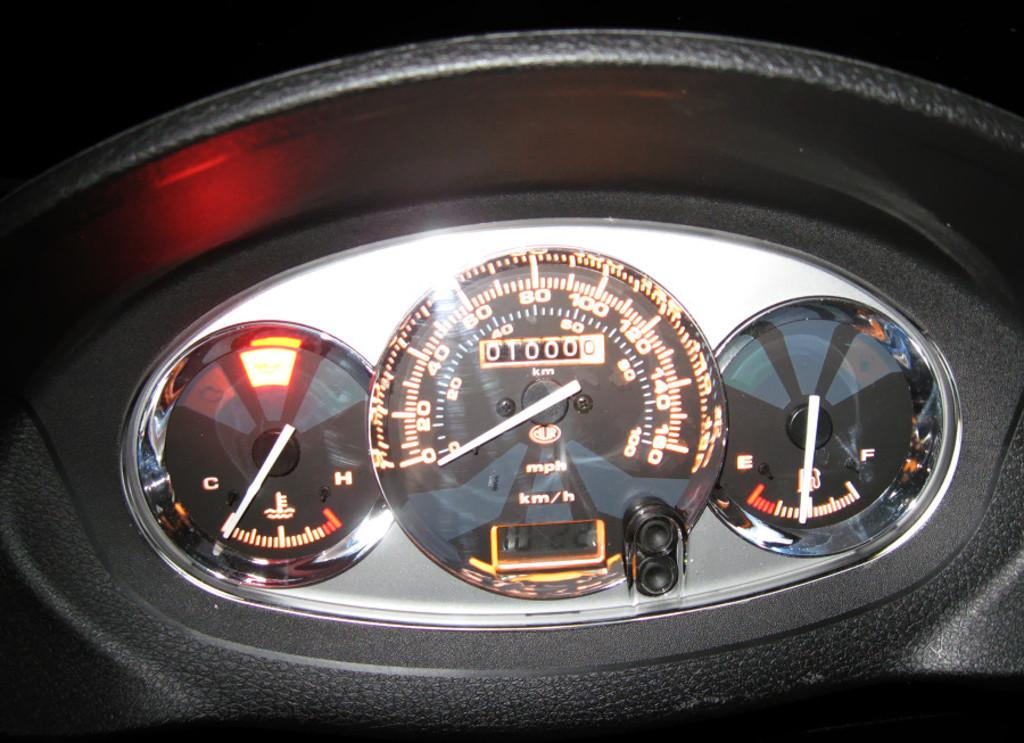What is the main subject of the image? The main subject of the image is the dashboard of a car. What type of caption can be seen on the dashboard in the image? There is no caption present on the dashboard in the image. How many steps are visible on the dashboard in the image? There are no steps visible on the dashboard in the image. Can you describe any folding mechanisms on the dashboard in the image? There are no folding mechanisms present on the dashboard in the image. 